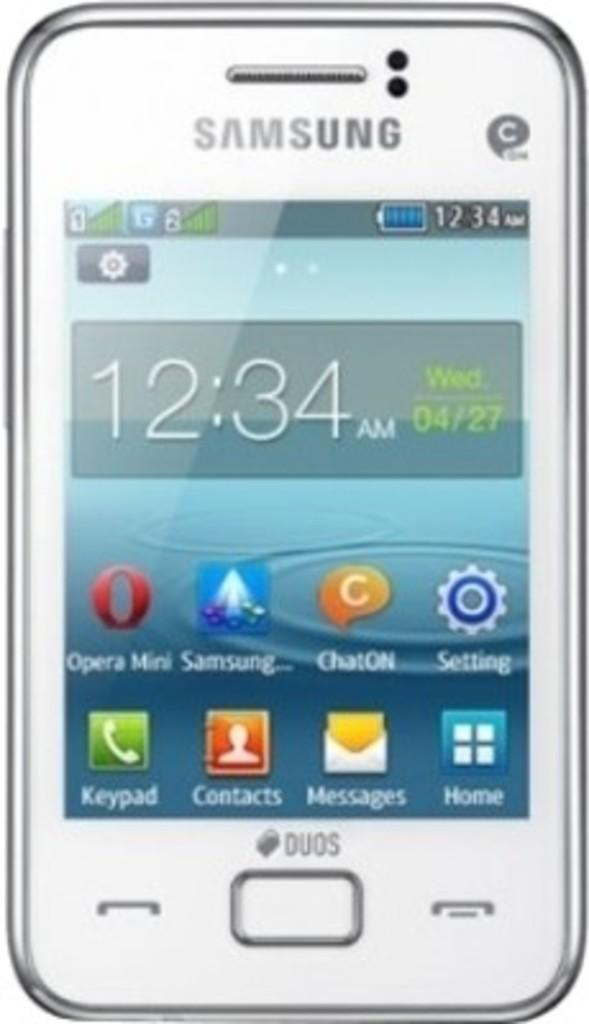<image>
Describe the image concisely. The white cell phone shown here is from Samsung 